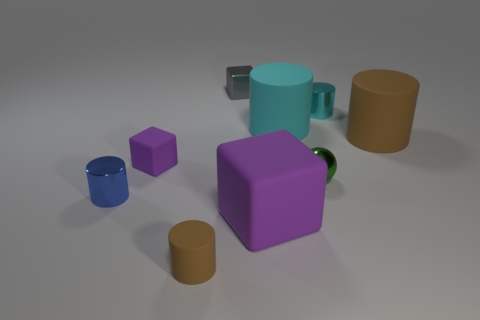Subtract all blue cylinders. How many cylinders are left? 4 Subtract all big cyan matte cylinders. How many cylinders are left? 4 Subtract all yellow cylinders. Subtract all blue spheres. How many cylinders are left? 5 Add 1 small cyan cylinders. How many objects exist? 10 Subtract all cubes. How many objects are left? 6 Add 1 brown matte objects. How many brown matte objects exist? 3 Subtract 0 red spheres. How many objects are left? 9 Subtract all rubber cubes. Subtract all large red balls. How many objects are left? 7 Add 2 small balls. How many small balls are left? 3 